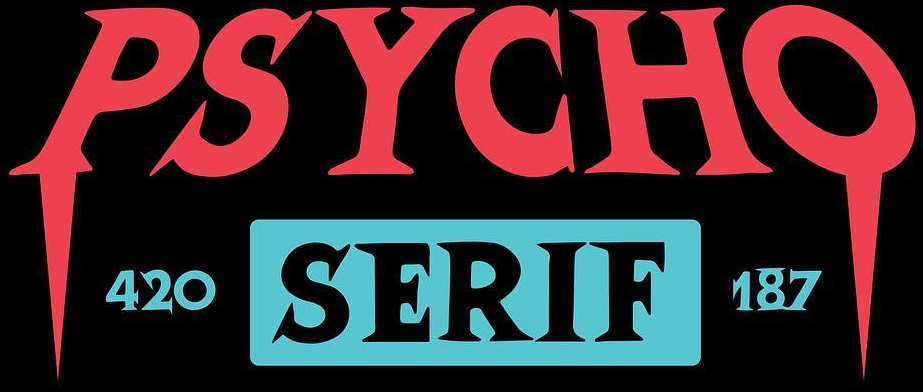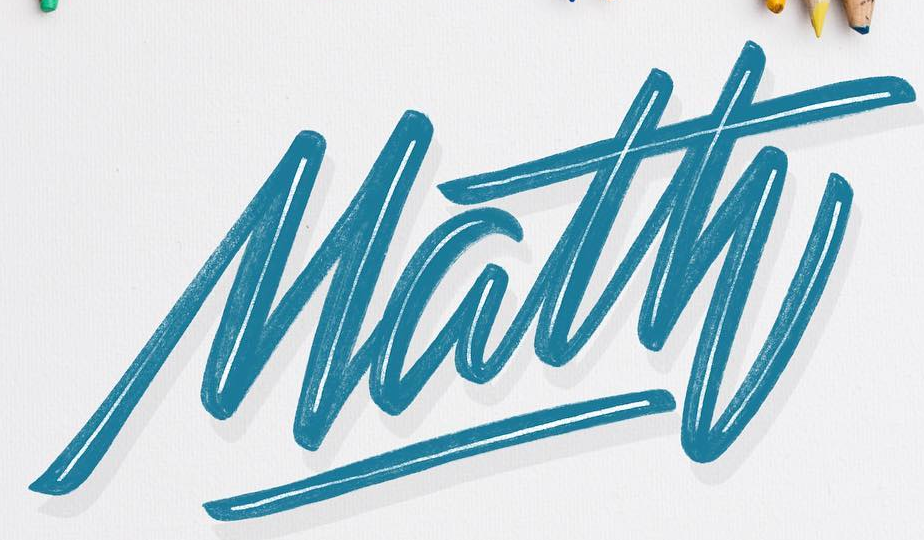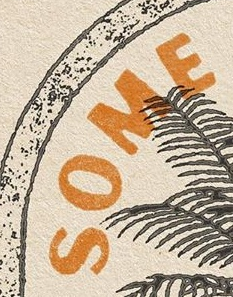What words can you see in these images in sequence, separated by a semicolon? PSYCHO; Math; SOME 